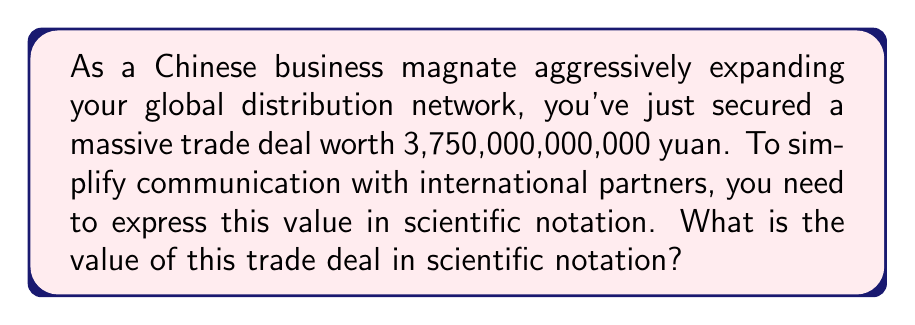Could you help me with this problem? To convert 3,750,000,000,000 yuan to scientific notation, we follow these steps:

1) Identify the first non-zero digit: 3

2) Move the decimal point to the right of this digit:
   $3.750000000000$

3) Count the number of places the decimal point was moved:
   It was moved 12 places to the left.

4) Express the number as a product of the decimal and a power of 10:
   $3.75 \times 10^{12}$

In scientific notation, we typically keep one digit before the decimal point and adjust the exponent accordingly. The number of zeros after the 5 doesn't affect the result in scientific notation.

Therefore, 3,750,000,000,000 in scientific notation is $3.75 \times 10^{12}$.
Answer: $3.75 \times 10^{12}$ yuan 